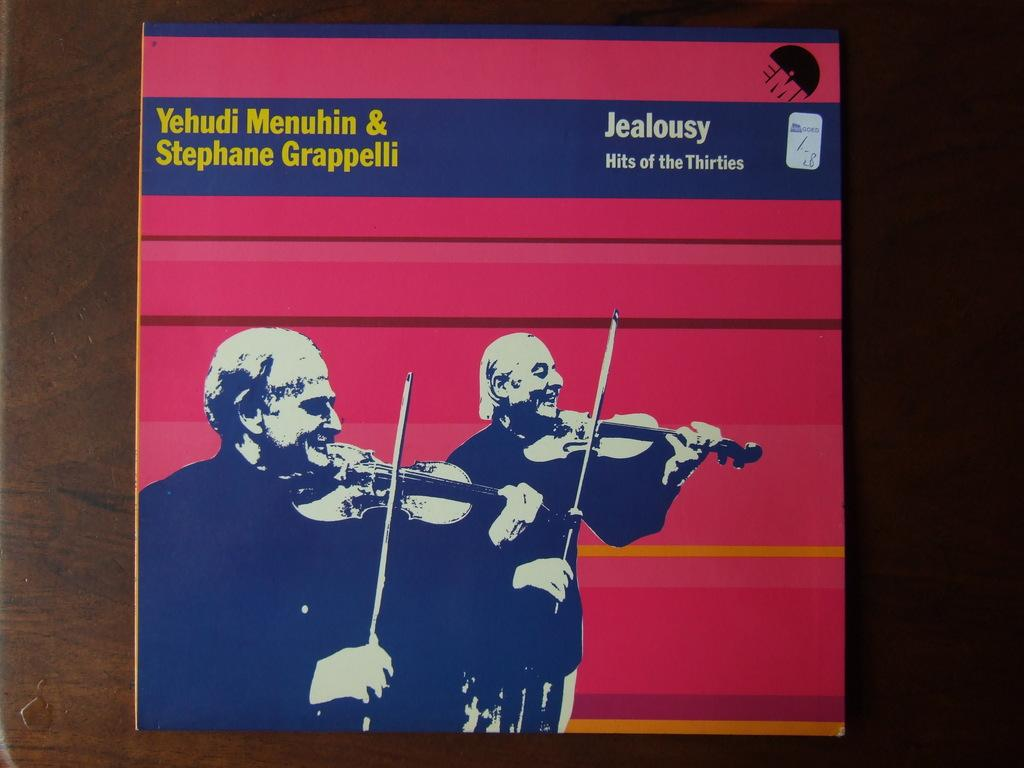<image>
Summarize the visual content of the image. Album cover titled Jealousy showing two men playing violins. 